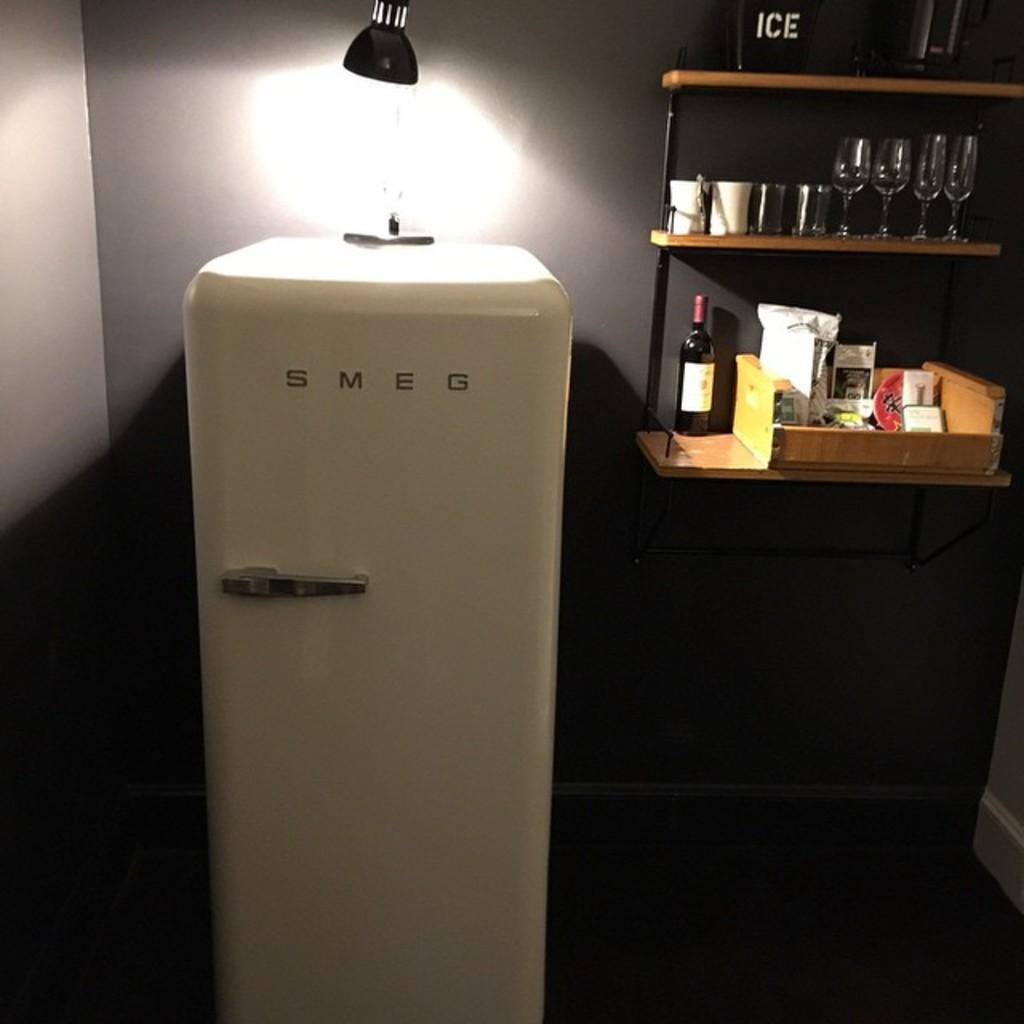<image>
Render a clear and concise summary of the photo. A fridge saying SMEG with a light on top 